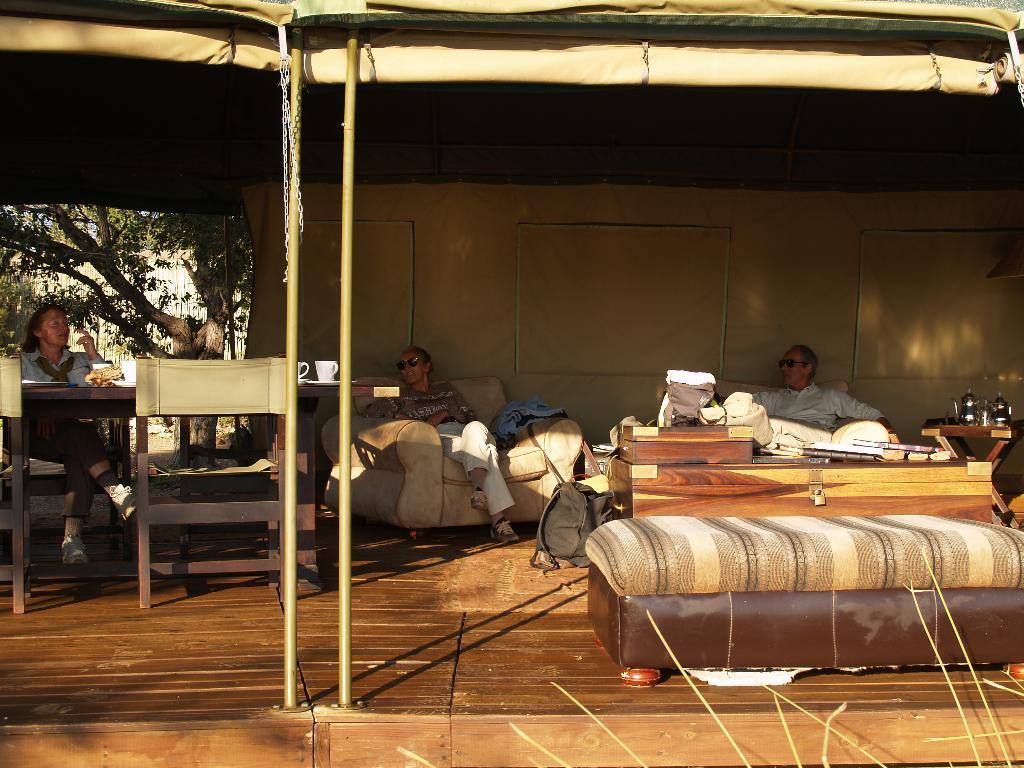Could you give a brief overview of what you see in this image? This looks like a tent. There are three people sitting on the couch. This is a table with some objects on it. Here is a luggage bag placed on the floor. This looks like a wooden box. And here is a tree at the background. 